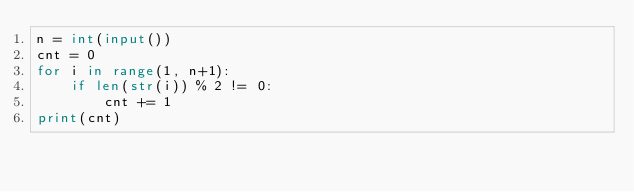<code> <loc_0><loc_0><loc_500><loc_500><_Python_>n = int(input())
cnt = 0
for i in range(1, n+1):
    if len(str(i)) % 2 != 0:
        cnt += 1
print(cnt)</code> 